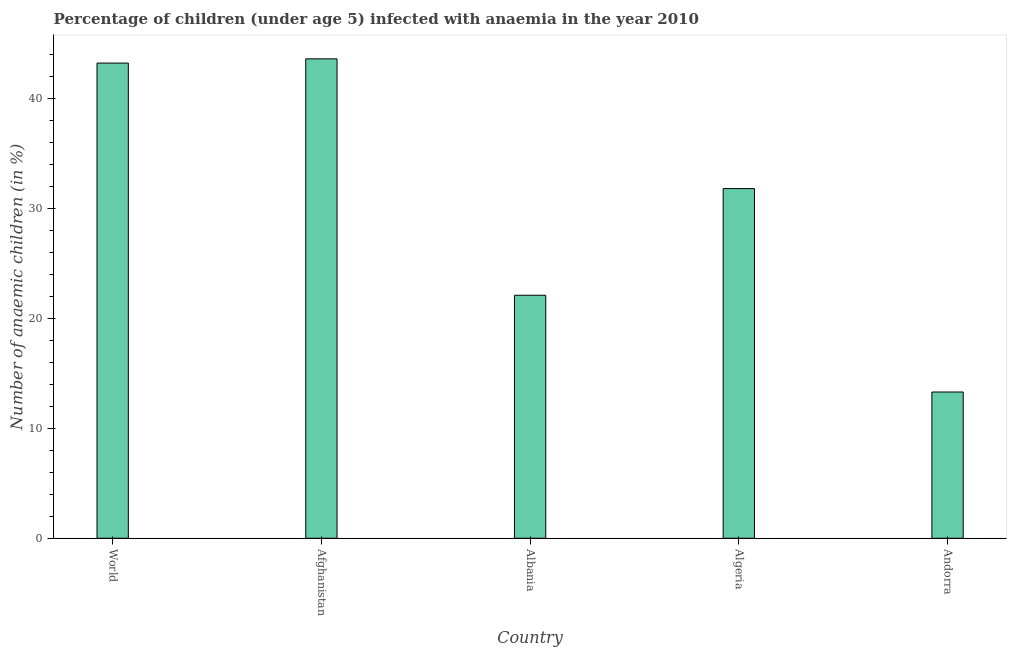Does the graph contain any zero values?
Offer a terse response. No. Does the graph contain grids?
Give a very brief answer. No. What is the title of the graph?
Your response must be concise. Percentage of children (under age 5) infected with anaemia in the year 2010. What is the label or title of the X-axis?
Make the answer very short. Country. What is the label or title of the Y-axis?
Your response must be concise. Number of anaemic children (in %). What is the number of anaemic children in Afghanistan?
Offer a terse response. 43.6. Across all countries, what is the maximum number of anaemic children?
Provide a short and direct response. 43.6. Across all countries, what is the minimum number of anaemic children?
Offer a very short reply. 13.3. In which country was the number of anaemic children maximum?
Ensure brevity in your answer.  Afghanistan. In which country was the number of anaemic children minimum?
Your answer should be very brief. Andorra. What is the sum of the number of anaemic children?
Ensure brevity in your answer.  154.01. What is the difference between the number of anaemic children in Afghanistan and Algeria?
Your answer should be compact. 11.8. What is the average number of anaemic children per country?
Make the answer very short. 30.8. What is the median number of anaemic children?
Your answer should be very brief. 31.8. What is the ratio of the number of anaemic children in Albania to that in Andorra?
Give a very brief answer. 1.66. Is the number of anaemic children in Andorra less than that in World?
Your answer should be very brief. Yes. Is the difference between the number of anaemic children in Afghanistan and World greater than the difference between any two countries?
Offer a very short reply. No. What is the difference between the highest and the second highest number of anaemic children?
Keep it short and to the point. 0.39. What is the difference between the highest and the lowest number of anaemic children?
Make the answer very short. 30.3. In how many countries, is the number of anaemic children greater than the average number of anaemic children taken over all countries?
Offer a very short reply. 3. Are all the bars in the graph horizontal?
Provide a succinct answer. No. What is the difference between two consecutive major ticks on the Y-axis?
Your answer should be very brief. 10. What is the Number of anaemic children (in %) of World?
Provide a succinct answer. 43.21. What is the Number of anaemic children (in %) in Afghanistan?
Your answer should be very brief. 43.6. What is the Number of anaemic children (in %) in Albania?
Your answer should be compact. 22.1. What is the Number of anaemic children (in %) of Algeria?
Give a very brief answer. 31.8. What is the difference between the Number of anaemic children (in %) in World and Afghanistan?
Ensure brevity in your answer.  -0.39. What is the difference between the Number of anaemic children (in %) in World and Albania?
Give a very brief answer. 21.11. What is the difference between the Number of anaemic children (in %) in World and Algeria?
Provide a short and direct response. 11.41. What is the difference between the Number of anaemic children (in %) in World and Andorra?
Keep it short and to the point. 29.91. What is the difference between the Number of anaemic children (in %) in Afghanistan and Algeria?
Your answer should be very brief. 11.8. What is the difference between the Number of anaemic children (in %) in Afghanistan and Andorra?
Offer a terse response. 30.3. What is the difference between the Number of anaemic children (in %) in Albania and Algeria?
Ensure brevity in your answer.  -9.7. What is the difference between the Number of anaemic children (in %) in Algeria and Andorra?
Your answer should be compact. 18.5. What is the ratio of the Number of anaemic children (in %) in World to that in Albania?
Your answer should be compact. 1.96. What is the ratio of the Number of anaemic children (in %) in World to that in Algeria?
Keep it short and to the point. 1.36. What is the ratio of the Number of anaemic children (in %) in World to that in Andorra?
Your answer should be compact. 3.25. What is the ratio of the Number of anaemic children (in %) in Afghanistan to that in Albania?
Ensure brevity in your answer.  1.97. What is the ratio of the Number of anaemic children (in %) in Afghanistan to that in Algeria?
Your response must be concise. 1.37. What is the ratio of the Number of anaemic children (in %) in Afghanistan to that in Andorra?
Give a very brief answer. 3.28. What is the ratio of the Number of anaemic children (in %) in Albania to that in Algeria?
Provide a short and direct response. 0.69. What is the ratio of the Number of anaemic children (in %) in Albania to that in Andorra?
Provide a short and direct response. 1.66. What is the ratio of the Number of anaemic children (in %) in Algeria to that in Andorra?
Give a very brief answer. 2.39. 